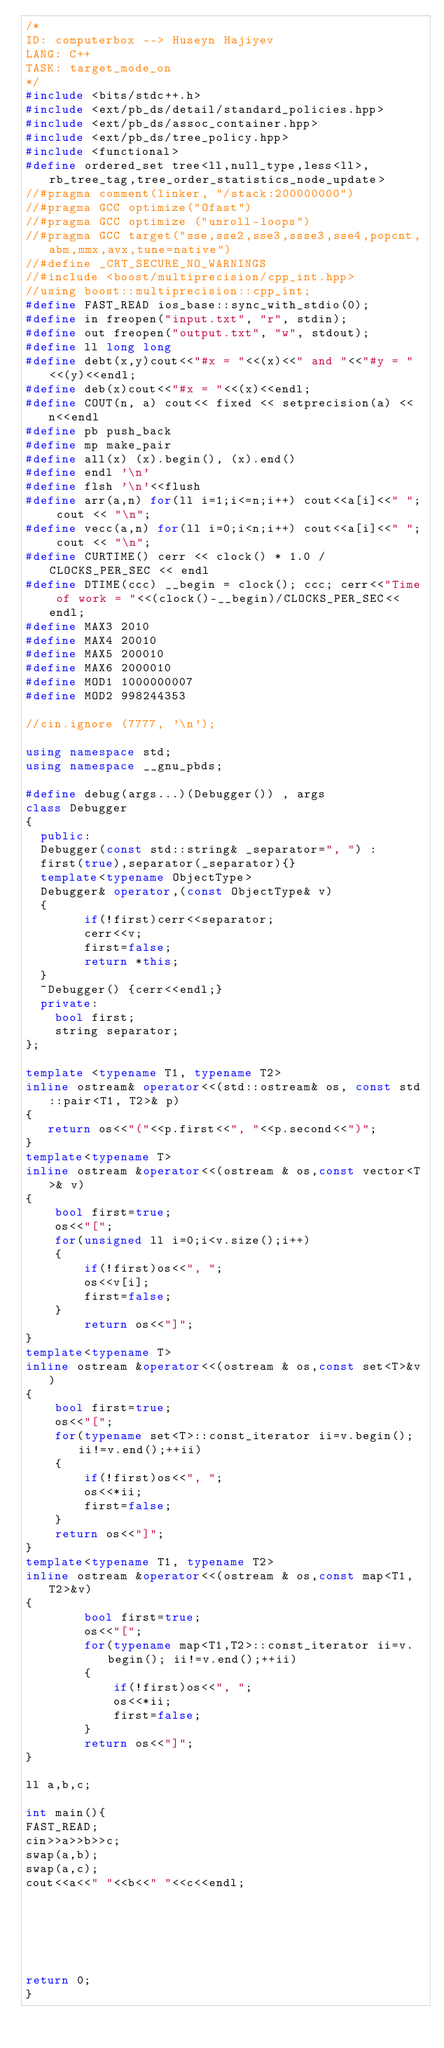Convert code to text. <code><loc_0><loc_0><loc_500><loc_500><_C++_>/*
ID: computerbox --> Huseyn Hajiyev
LANG: C++
TASK: target_mode_on
*/
#include <bits/stdc++.h>
#include <ext/pb_ds/detail/standard_policies.hpp>
#include <ext/pb_ds/assoc_container.hpp>
#include <ext/pb_ds/tree_policy.hpp>
#include <functional>
#define ordered_set tree<ll,null_type,less<ll>,rb_tree_tag,tree_order_statistics_node_update>
//#pragma comment(linker, "/stack:200000000")
//#pragma GCC optimize("Ofast")
//#pragma GCC optimize ("unroll-loops")
//#pragma GCC target("sse,sse2,sse3,ssse3,sse4,popcnt,abm,mmx,avx,tune=native")
//#define _CRT_SECURE_NO_WARNINGS
//#include <boost/multiprecision/cpp_int.hpp>
//using boost::multiprecision::cpp_int;
#define FAST_READ ios_base::sync_with_stdio(0);
#define in freopen("input.txt", "r", stdin);
#define out freopen("output.txt", "w", stdout);
#define ll long long
#define debt(x,y)cout<<"#x = "<<(x)<<" and "<<"#y = "<<(y)<<endl;
#define deb(x)cout<<"#x = "<<(x)<<endl;
#define COUT(n, a) cout<< fixed << setprecision(a) << n<<endl
#define pb push_back
#define mp make_pair
#define all(x) (x).begin(), (x).end()
#define endl '\n'
#define flsh '\n'<<flush
#define arr(a,n) for(ll i=1;i<=n;i++) cout<<a[i]<<" "; cout << "\n";
#define vecc(a,n) for(ll i=0;i<n;i++) cout<<a[i]<<" "; cout << "\n";
#define CURTIME() cerr << clock() * 1.0 / CLOCKS_PER_SEC << endl
#define DTIME(ccc) __begin = clock(); ccc; cerr<<"Time of work = "<<(clock()-__begin)/CLOCKS_PER_SEC<<endl;
#define MAX3 2010
#define MAX4 20010
#define MAX5 200010
#define MAX6 2000010
#define MOD1 1000000007
#define MOD2 998244353

//cin.ignore (7777, '\n');

using namespace std;
using namespace __gnu_pbds;

#define debug(args...)(Debugger()) , args
class Debugger
{
  public:
  Debugger(const std::string& _separator=", ") :
  first(true),separator(_separator){}
  template<typename ObjectType>
  Debugger& operator,(const ObjectType& v)
  {
        if(!first)cerr<<separator;
        cerr<<v;
        first=false;
        return *this;
  }
  ~Debugger() {cerr<<endl;}      
  private:
    bool first;
    string separator;
};
 
template <typename T1, typename T2>
inline ostream& operator<<(std::ostream& os, const std::pair<T1, T2>& p)
{
   return os<<"("<<p.first<<", "<<p.second<<")";
}
template<typename T>
inline ostream &operator<<(ostream & os,const vector<T>& v)
{
    bool first=true;
    os<<"[";
    for(unsigned ll i=0;i<v.size();i++)
    {
        if(!first)os<<", ";
        os<<v[i];
        first=false;
    }
        return os<<"]";
}
template<typename T>
inline ostream &operator<<(ostream & os,const set<T>&v)
{
    bool first=true;
    os<<"[";
    for(typename set<T>::const_iterator ii=v.begin();ii!=v.end();++ii)
    {
        if(!first)os<<", ";
        os<<*ii;
        first=false;
    }
    return os<<"]";
}
template<typename T1, typename T2>
inline ostream &operator<<(ostream & os,const map<T1, T2>&v)
{
        bool first=true;
        os<<"[";
        for(typename map<T1,T2>::const_iterator ii=v.begin(); ii!=v.end();++ii)
        {
            if(!first)os<<", ";
            os<<*ii;
            first=false;
        }
        return os<<"]";
}

ll a,b,c;

int main(){
FAST_READ;
cin>>a>>b>>c;
swap(a,b);
swap(a,c);
cout<<a<<" "<<b<<" "<<c<<endl;






return 0;
} 
</code> 